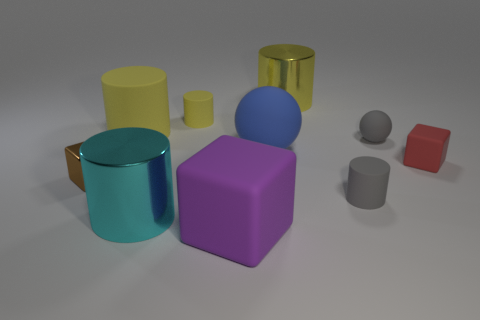What number of cubes are large blue rubber things or red rubber objects?
Your answer should be compact. 1. There is a cylinder that is the same color as the small sphere; what is its size?
Your answer should be very brief. Small. Is the number of big metal things that are in front of the big cyan cylinder less than the number of yellow rubber cylinders?
Your answer should be very brief. Yes. There is a thing that is behind the gray matte ball and on the left side of the big cyan cylinder; what is its color?
Give a very brief answer. Yellow. How many other objects are there of the same shape as the big blue rubber object?
Make the answer very short. 1. Is the number of metal objects to the right of the tiny metallic thing less than the number of big yellow matte things that are in front of the blue object?
Offer a very short reply. No. Is the material of the red block the same as the gray object that is in front of the small brown metallic thing?
Provide a short and direct response. Yes. Are there any other things that have the same material as the tiny gray cylinder?
Your response must be concise. Yes. Are there more big matte balls than large shiny cylinders?
Ensure brevity in your answer.  No. There is a shiny object left of the large matte thing that is to the left of the big matte object in front of the big blue rubber ball; what shape is it?
Give a very brief answer. Cube. 